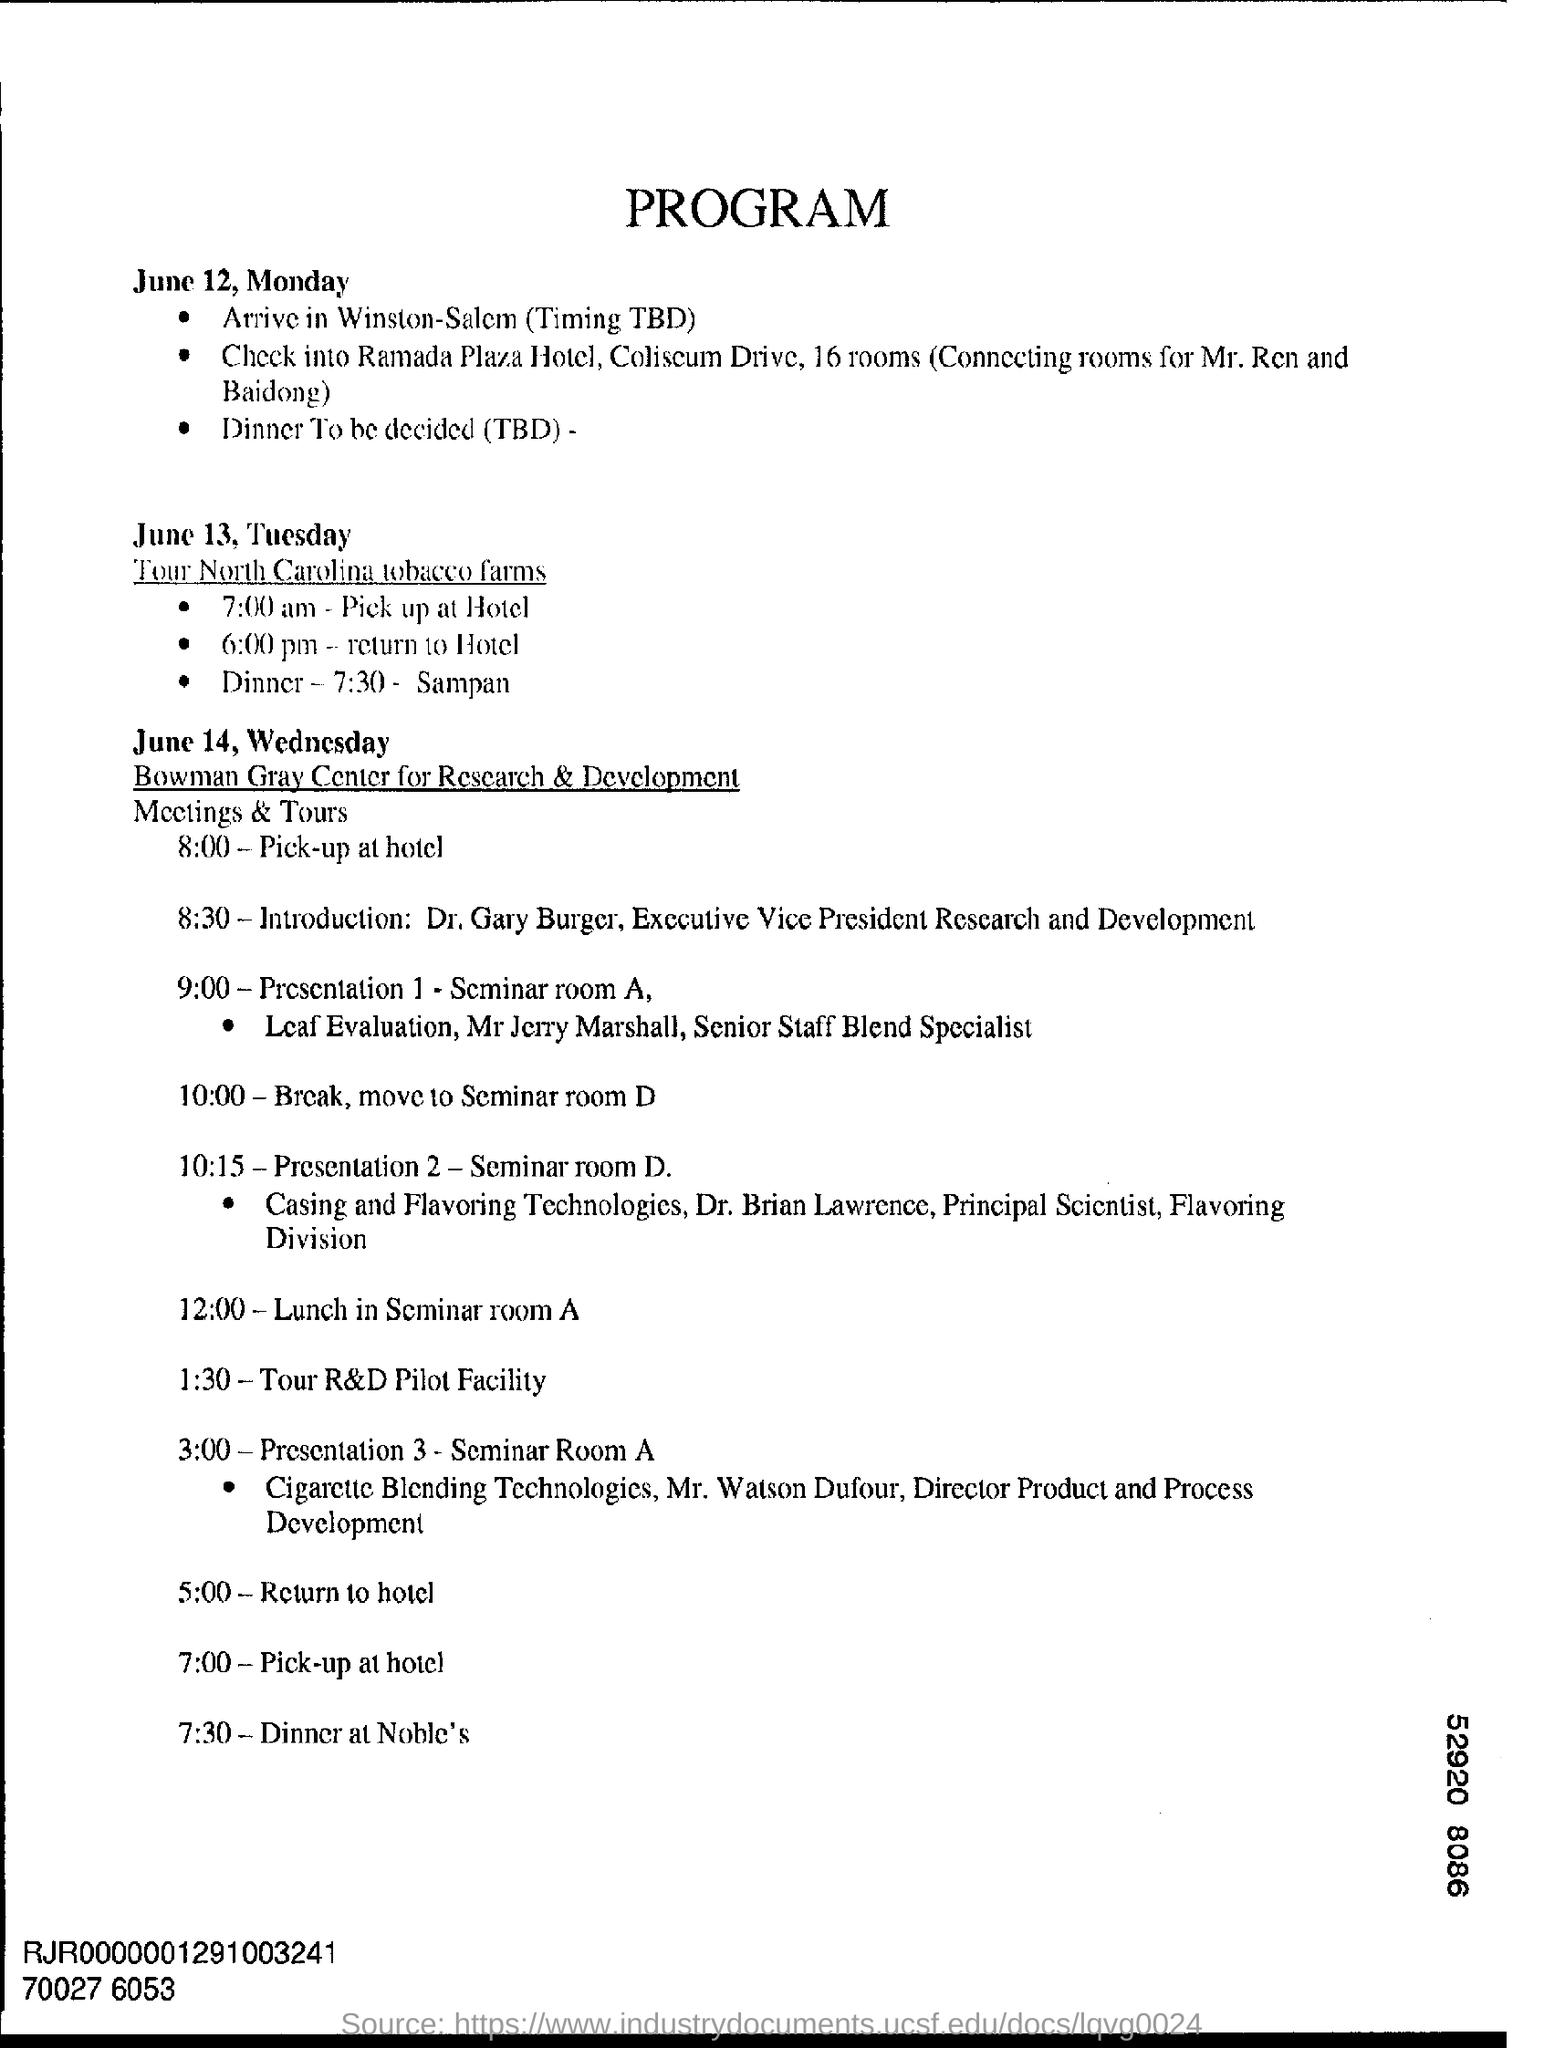Mention a couple of crucial points in this snapshot. On June 14th, Wednesday, at 7:30 PM, the group will be dining at Noble's. The destination is Winston-Salem, The first date mentioned is June 12, which is a Monday. 